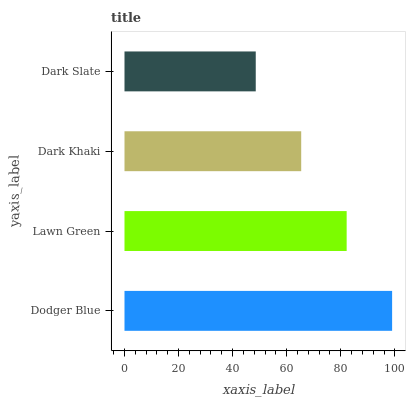Is Dark Slate the minimum?
Answer yes or no. Yes. Is Dodger Blue the maximum?
Answer yes or no. Yes. Is Lawn Green the minimum?
Answer yes or no. No. Is Lawn Green the maximum?
Answer yes or no. No. Is Dodger Blue greater than Lawn Green?
Answer yes or no. Yes. Is Lawn Green less than Dodger Blue?
Answer yes or no. Yes. Is Lawn Green greater than Dodger Blue?
Answer yes or no. No. Is Dodger Blue less than Lawn Green?
Answer yes or no. No. Is Lawn Green the high median?
Answer yes or no. Yes. Is Dark Khaki the low median?
Answer yes or no. Yes. Is Dark Slate the high median?
Answer yes or no. No. Is Dodger Blue the low median?
Answer yes or no. No. 